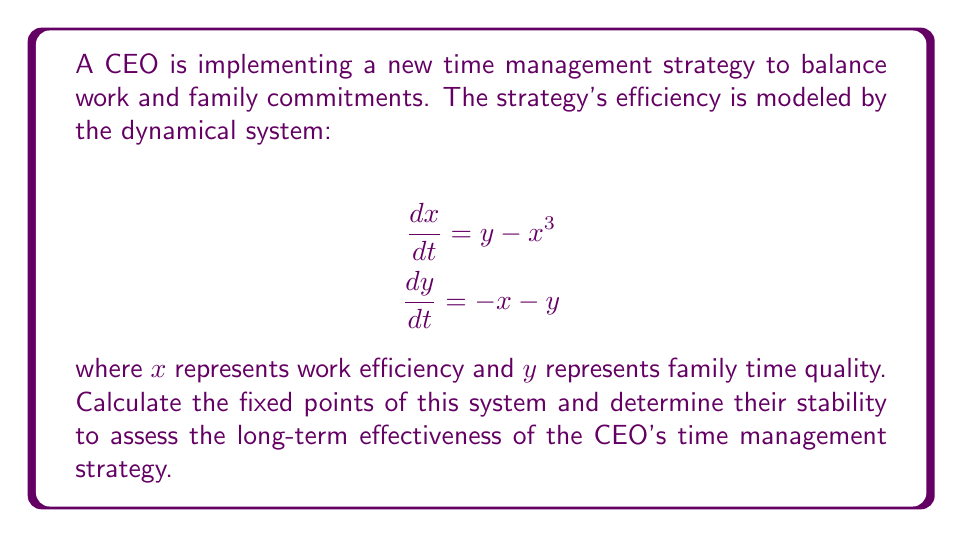What is the answer to this math problem? 1. To find the fixed points, set both equations to zero:
   $$y - x^3 = 0$$
   $$-x - y = 0$$

2. From the second equation: $y = -x$

3. Substitute this into the first equation:
   $$-x - x^3 = 0$$
   $$-x(1 + x^2) = 0$$

4. Solve for x:
   $x = 0$ or $x^2 = -1$

5. The only real solution is $x = 0$, which gives $y = 0$

6. Therefore, the only fixed point is $(0, 0)$

7. To determine stability, calculate the Jacobian matrix at $(0, 0)$:
   $$J = \begin{bmatrix}
   \frac{\partial}{\partial x}(y - x^3) & \frac{\partial}{\partial y}(y - x^3) \\
   \frac{\partial}{\partial x}(-x - y) & \frac{\partial}{\partial y}(-x - y)
   \end{bmatrix} = \begin{bmatrix}
   -3x^2 & 1 \\
   -1 & -1
   \end{bmatrix}$$

8. At $(0, 0)$, the Jacobian becomes:
   $$J_{(0,0)} = \begin{bmatrix}
   0 & 1 \\
   -1 & -1
   \end{bmatrix}$$

9. Calculate the eigenvalues:
   $$\det(J_{(0,0)} - \lambda I) = \begin{vmatrix}
   -\lambda & 1 \\
   -1 & -1-\lambda
   \end{vmatrix} = \lambda^2 + \lambda + 1 = 0$$

10. Solve for λ:
    $$\lambda = \frac{-1 \pm \sqrt{1^2 - 4(1)(1)}}{2(1)} = \frac{-1 \pm \sqrt{-3}}{2}$$

11. The eigenvalues are complex with negative real parts, indicating a stable spiral.
Answer: Fixed point: $(0, 0)$; Stable spiral 